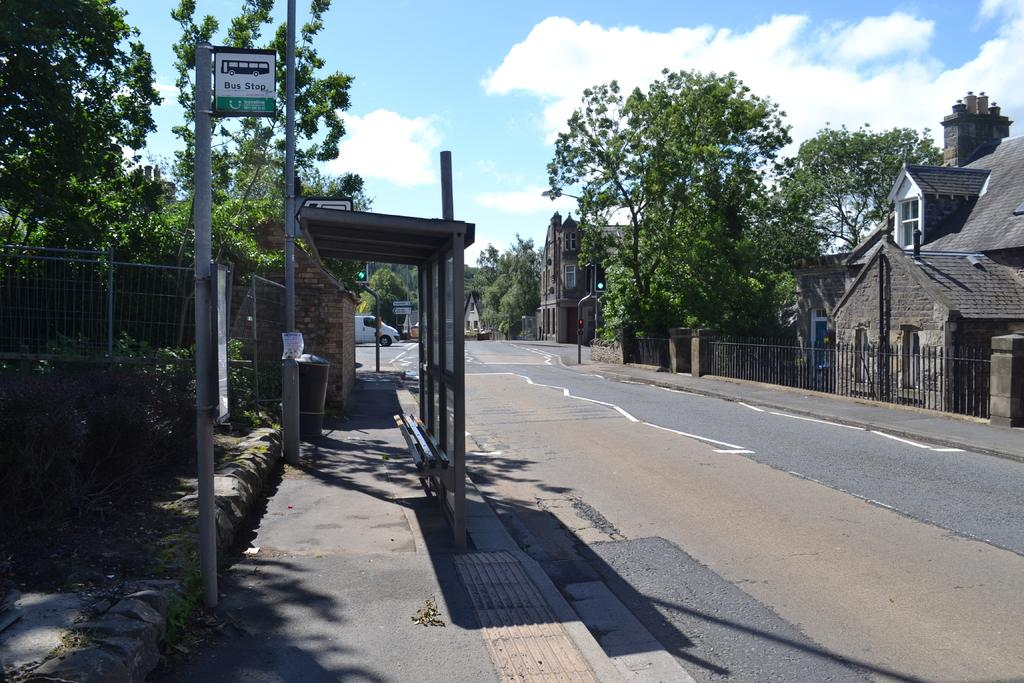What type of structures can be seen in the image? There are buildings in the image. What other natural elements are present in the image? There are trees in the image. What is the purpose of the structure near the road in the image? There is a bus stop in the image. What information might be conveyed by the board with text in the image? The board with text might display information about bus schedules or advertisements. What are the poles used for in the image? The poles might be used for supporting electrical wires or streetlights. What type of vehicle is on the road in the image? There is a vehicle on the road in the image. How would you describe the weather in the image? The sky is blue and cloudy in the image, suggesting a partly cloudy day. Are there any fairies visible in the image? No, there are no fairies present in the image. Is there a battle taking place in the image? No, there is no battle depicted in the image. 